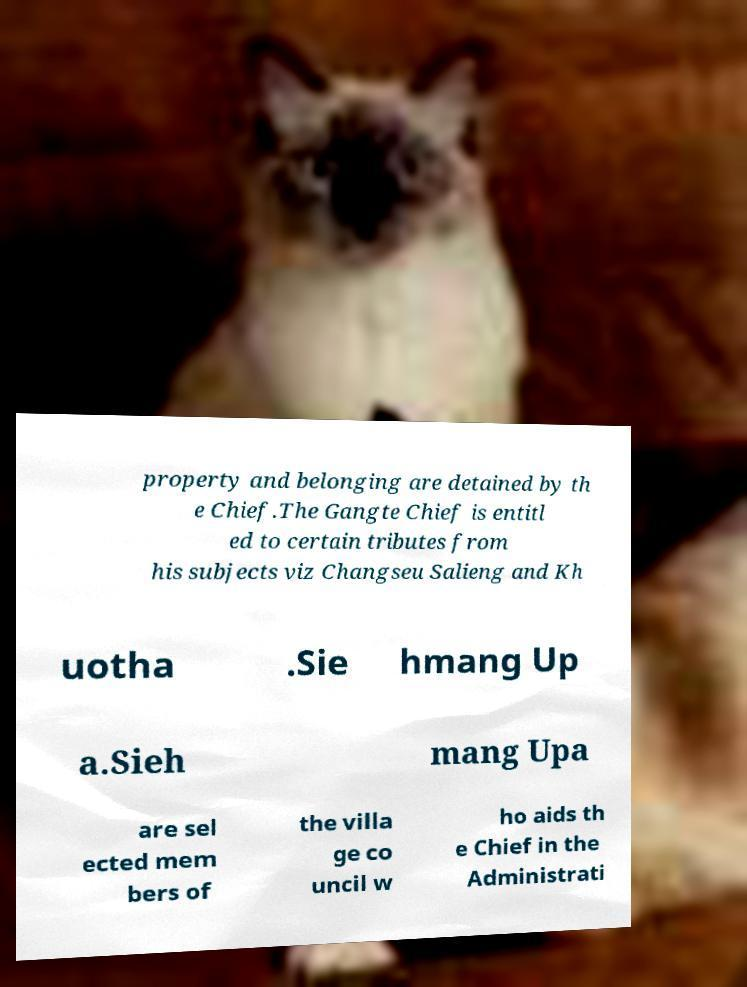I need the written content from this picture converted into text. Can you do that? property and belonging are detained by th e Chief.The Gangte Chief is entitl ed to certain tributes from his subjects viz Changseu Salieng and Kh uotha .Sie hmang Up a.Sieh mang Upa are sel ected mem bers of the villa ge co uncil w ho aids th e Chief in the Administrati 